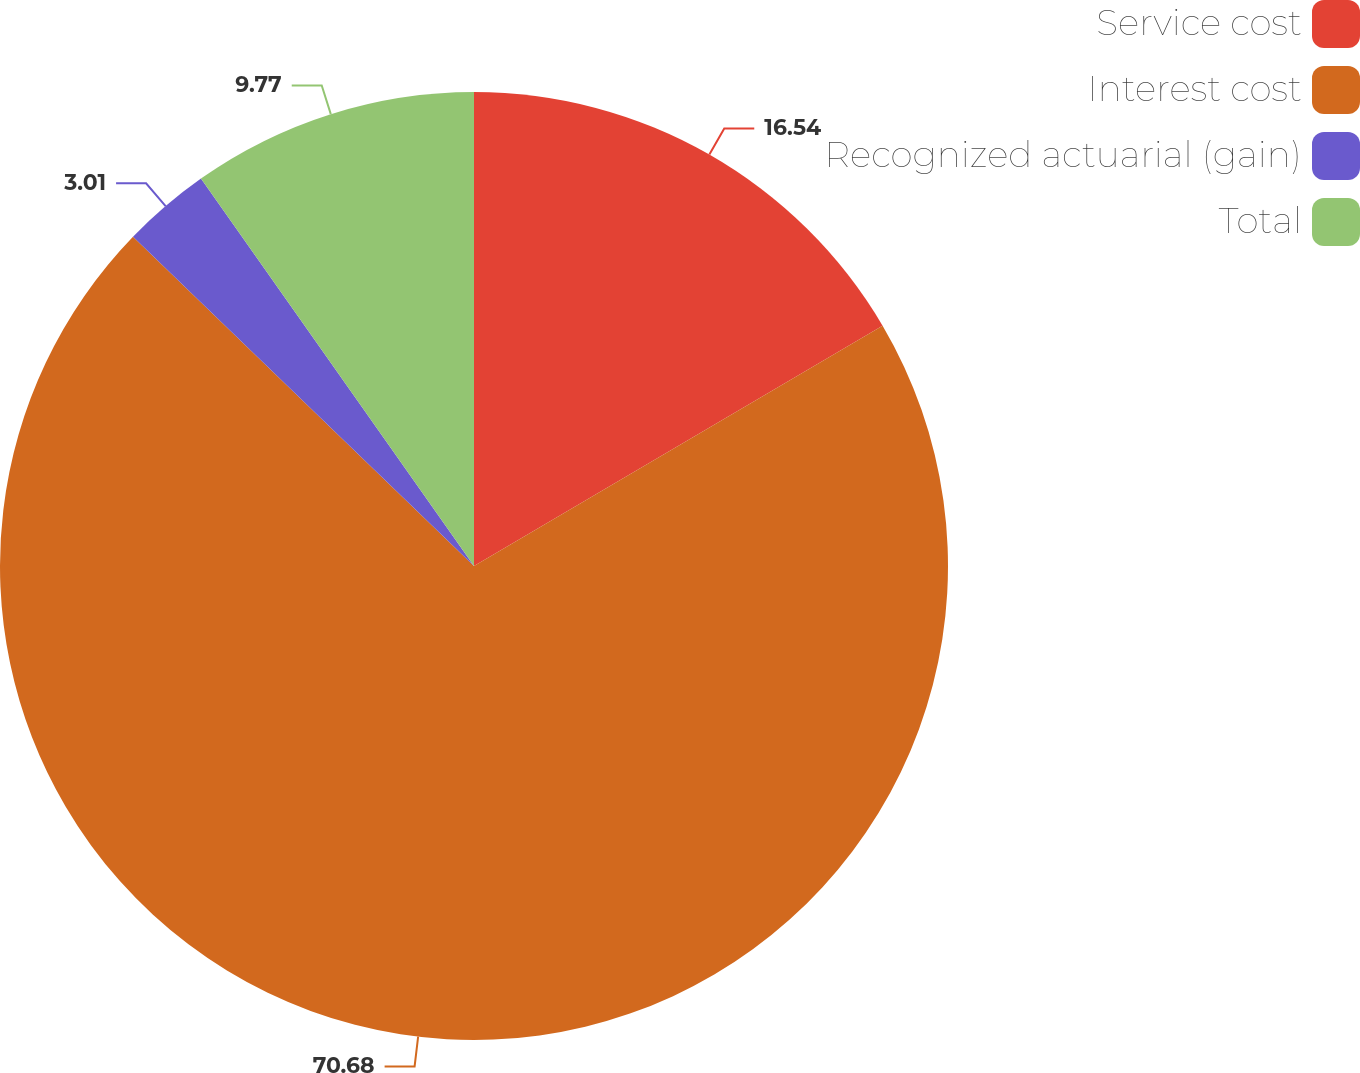Convert chart. <chart><loc_0><loc_0><loc_500><loc_500><pie_chart><fcel>Service cost<fcel>Interest cost<fcel>Recognized actuarial (gain)<fcel>Total<nl><fcel>16.54%<fcel>70.68%<fcel>3.01%<fcel>9.77%<nl></chart> 